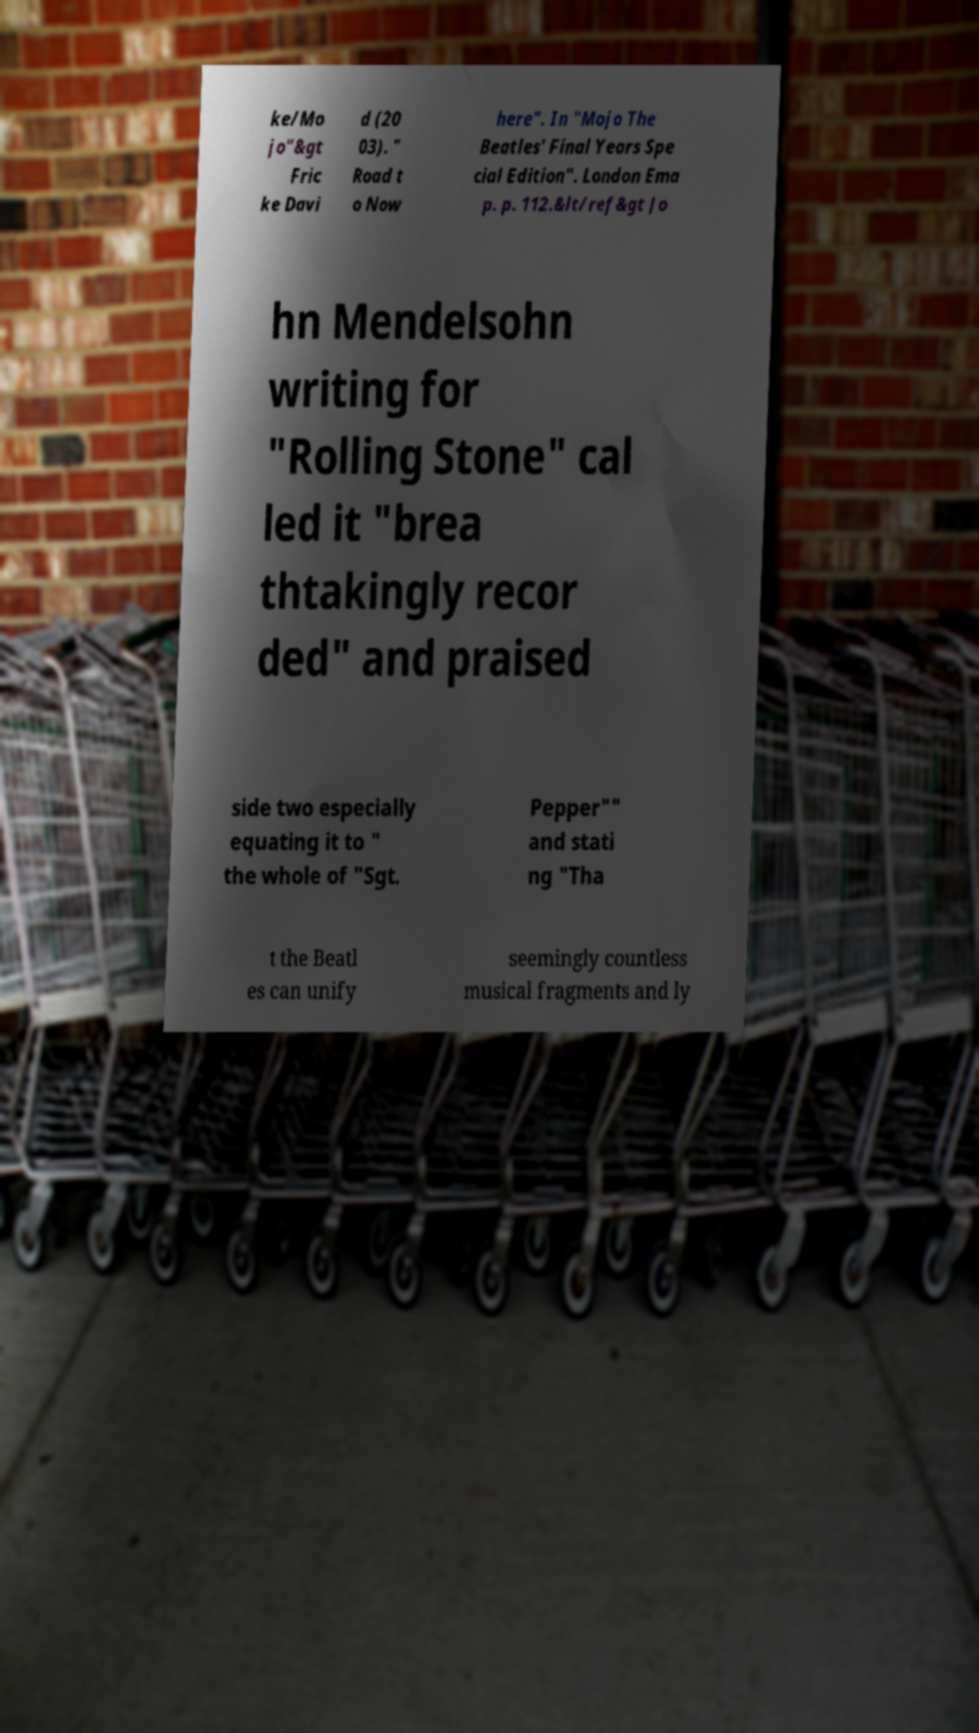Please read and relay the text visible in this image. What does it say? ke/Mo jo"&gt Fric ke Davi d (20 03). " Road t o Now here". In "Mojo The Beatles' Final Years Spe cial Edition". London Ema p. p. 112.&lt/ref&gt Jo hn Mendelsohn writing for "Rolling Stone" cal led it "brea thtakingly recor ded" and praised side two especially equating it to " the whole of "Sgt. Pepper"" and stati ng "Tha t the Beatl es can unify seemingly countless musical fragments and ly 